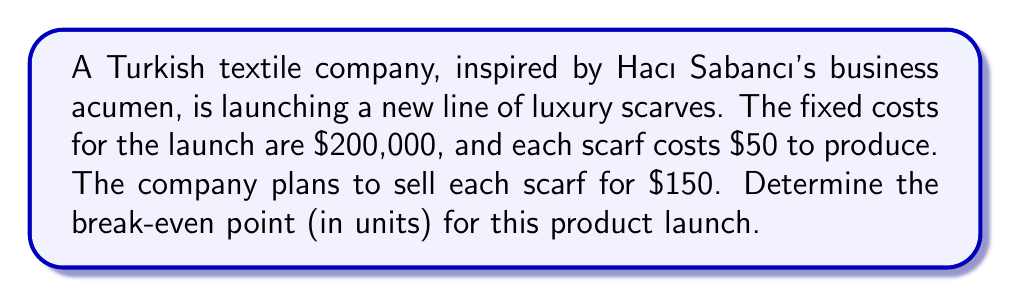Solve this math problem. Let's approach this step-by-step:

1) First, let's define our variables:
   $x$ = number of scarves sold (break-even point)
   $FC$ = Fixed Costs
   $P$ = Price per scarf
   $V$ = Variable Cost per scarf

2) We know:
   $FC = 200,000$
   $P = 150$
   $V = 50$

3) The break-even point occurs when Total Revenue equals Total Costs:
   $TR = TC$

4) We can express this as:
   $Px = FC + Vx$

5) Substituting our known values:
   $150x = 200,000 + 50x$

6) Solve for $x$:
   $150x - 50x = 200,000$
   $100x = 200,000$

7) Divide both sides by 100:
   $x = 2,000$

Therefore, the company needs to sell 2,000 scarves to break even.
Answer: 2,000 scarves 